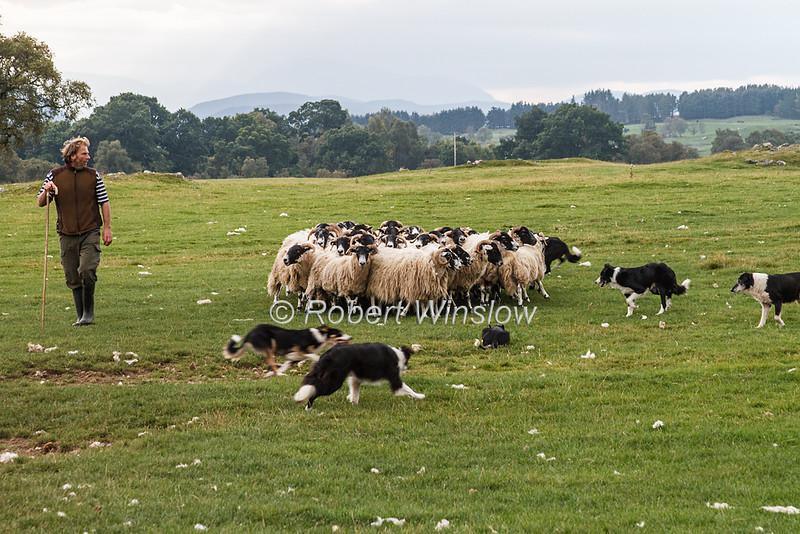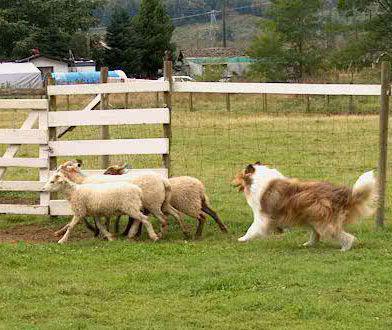The first image is the image on the left, the second image is the image on the right. Analyze the images presented: Is the assertion "The right photo contains exactly three sheep." valid? Answer yes or no. Yes. 